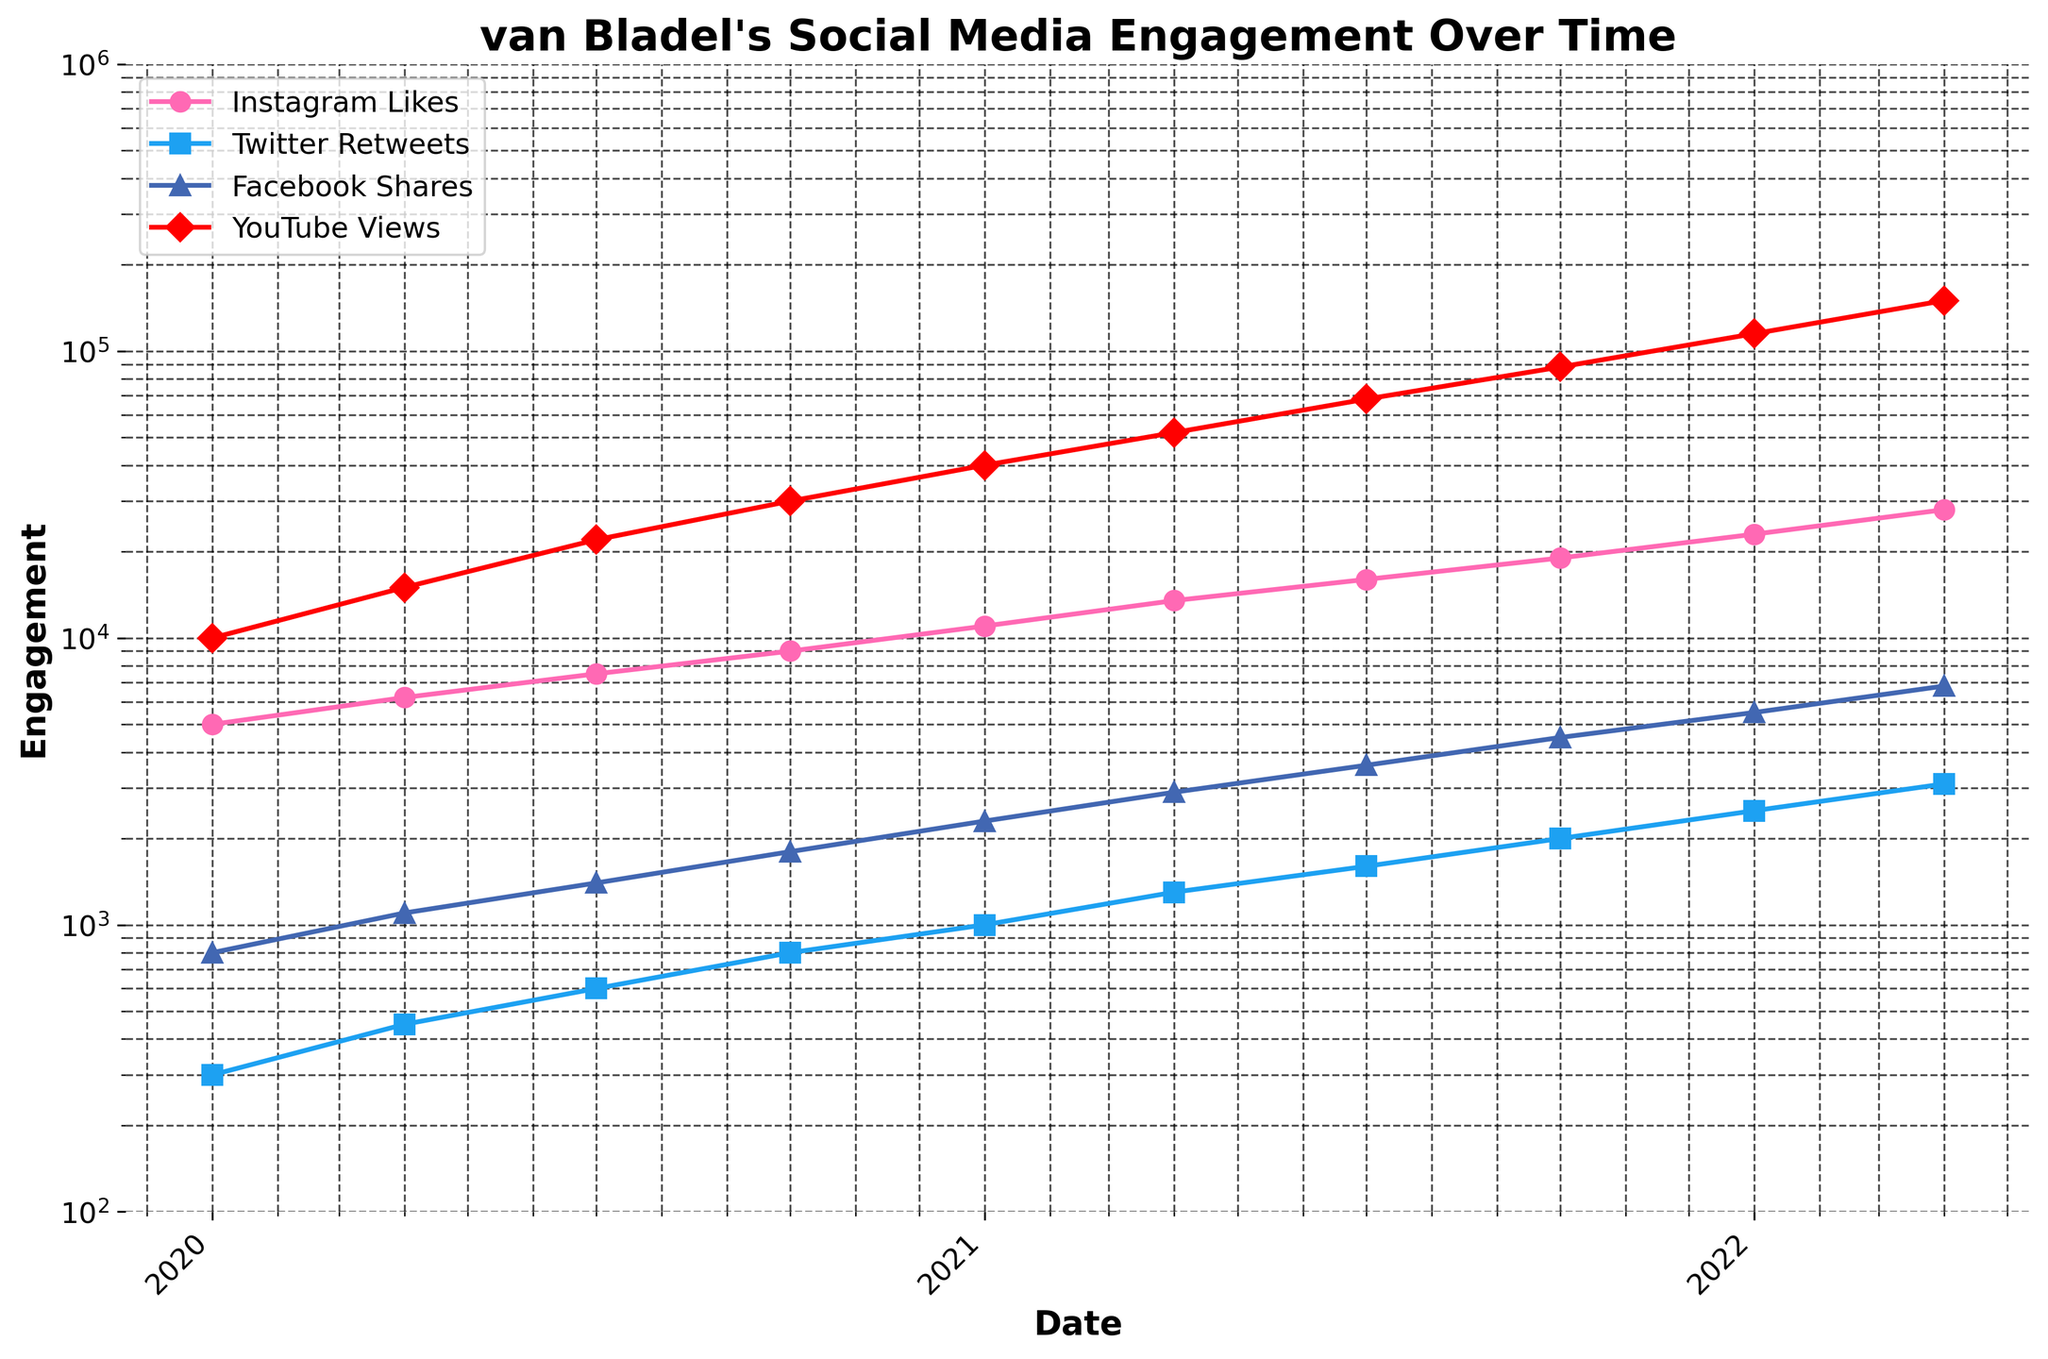What is the title of the figure? The title is written at the top of the figure and summarizes the main topic. It mentions van Bladel and the type of data visualized, which is social media engagement over time.
Answer: van Bladel's Social Media Engagement Over Time What are the social media platforms included in the figure? The platforms are listed in the legend of the plot. Each platform's engagement metrics are displayed with a different color and marker.
Answer: Instagram, Twitter, Facebook, YouTube What is the range of the y-axis? The y-axis is labeled "Engagement" and uses a logarithmic scale, as indicated by the spacing of the ticks. The minimum value starts at 100 and the maximum value reaches up to 1,000,000.
Answer: 100 to 1,000,000 Which platform shows the highest engagement at the end of the time period? At the end of the time period (2022-04-01), YouTube Views are the highest, which can be observed as being the uppermost line on the last date on the x-axis.
Answer: YouTube Which year shows a noticeable increase across all platforms? By examining the x-axis, you can see a significant upward trend in engagement metrics for all platforms starting in 2020 and continuing through to 2021. This suggests a noticeable increase during that period.
Answer: 2020-2021 What is the approximate YouTube Views value at the end of 2021? Find the point on the YouTube line that corresponds to the end of 2021. The approximate value is close to 88,000 as per the plotted data.
Answer: 88,000 How much did Twitter Retweets increase from 2020-01-01 to 2022-04-01? Find the Twitter Retweets value at the start and end dates. Subtract the initial value from the final value (3100 - 300).
Answer: 2,800 Which platform had the least increase from 2020-01-01 to 2021-01-01? Compare the increase in engagement for each platform over this period. Twitter Retweets initially increase by only 700 (1000 - 300), which is the smallest increase.
Answer: Twitter How many data points are plotted for each platform? Observe the points plotted on the lines for each platform. Each line has a point corresponding to all dates in the dataset. There are 10 points for each line.
Answer: 10 At what date did Facebook Shares reach 4,500? Look for the point where the Facebook line crosses the 4,500 mark. This happens around the 2021-10-01 date.
Answer: 2021-10-01 